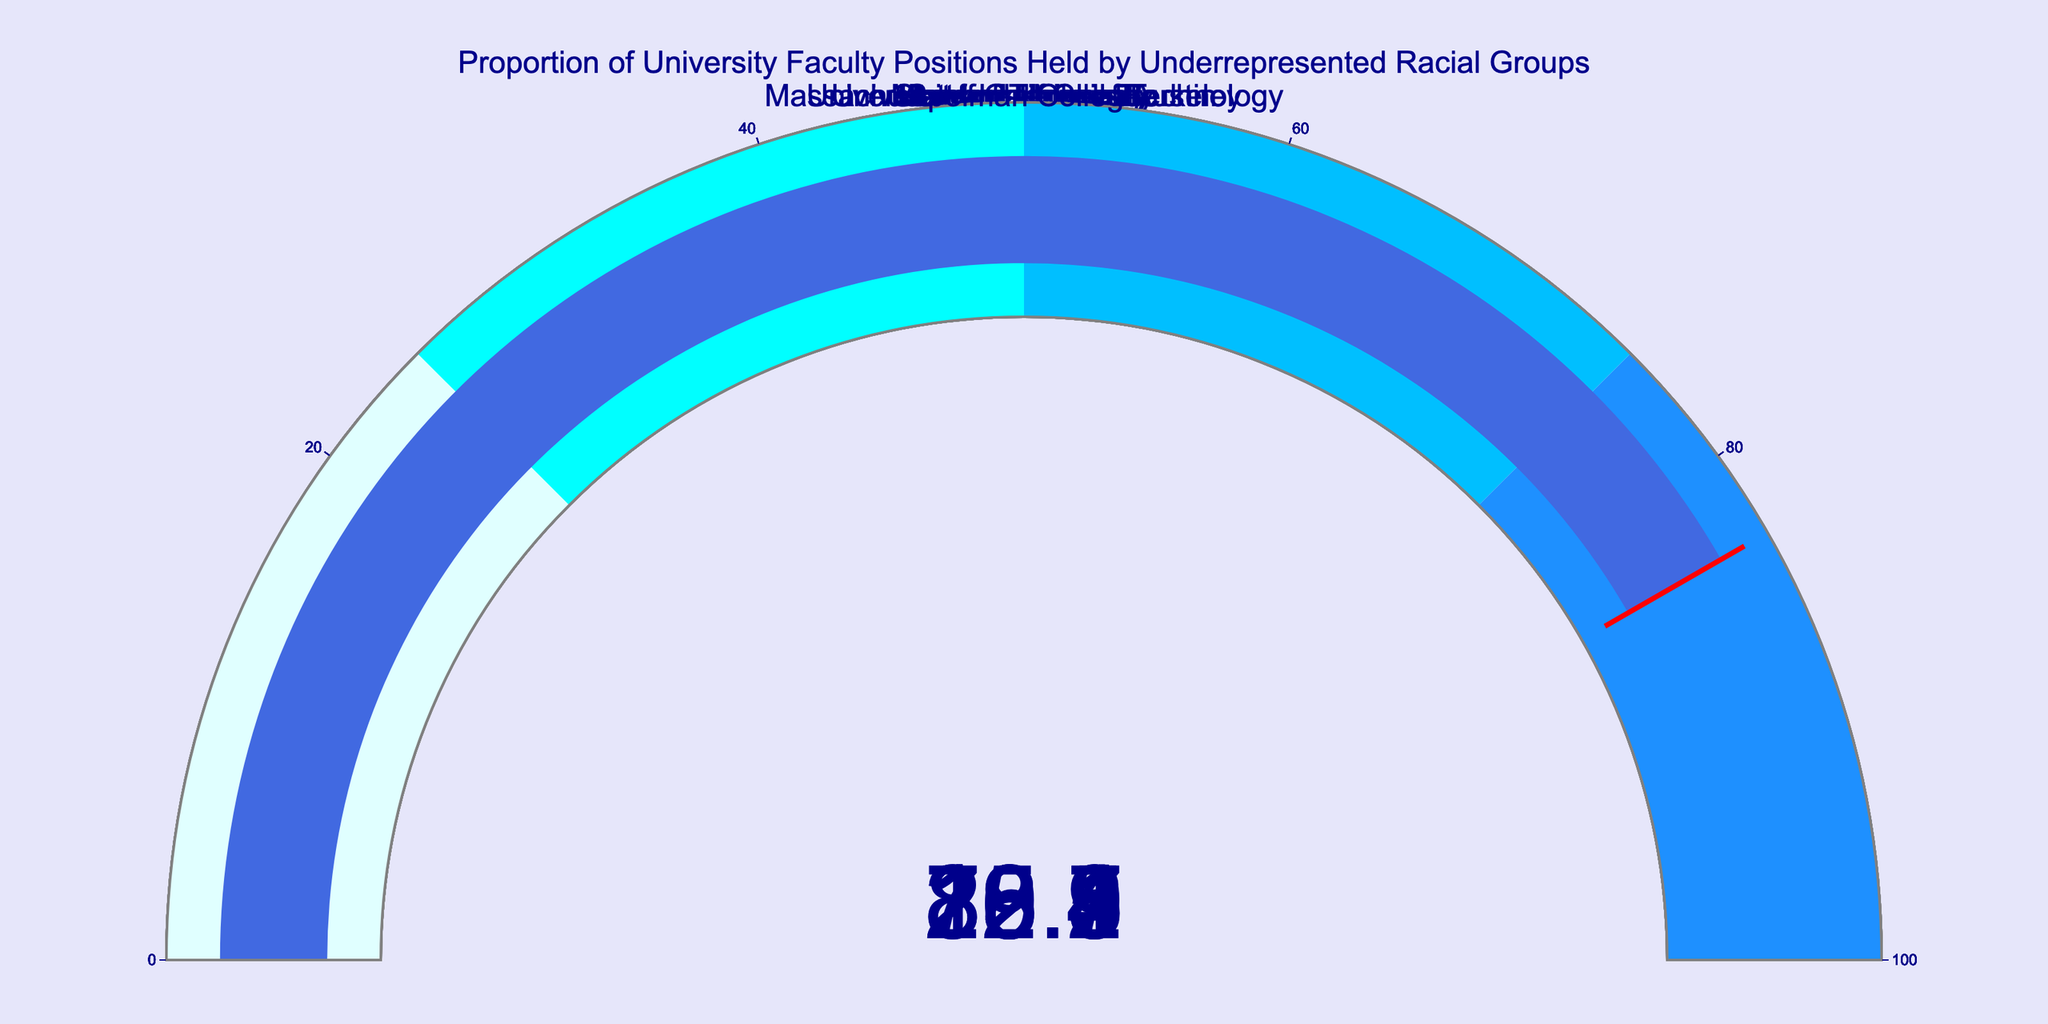What is the title of the plot? The title of the plot is usually displayed at the top. In this plot, it is clearly shown as "Proportion of University Faculty Positions Held by Underrepresented Racial Groups".
Answer: Proportion of University Faculty Positions Held by Underrepresented Racial Groups Which institution has the highest percentage of faculty positions held by underrepresented racial groups? To find the institution with the highest percentage, look at each gauge and compare the percentages displayed. Morehouse College has the highest percentage at 89.1%.
Answer: Morehouse College How many institutions are depicted in the plot? By counting the number of gauges, we identify that there are eight different institutions represented in the plot.
Answer: 8 What is the percentage of faculty positions held by underrepresented racial groups at Harvard University? The gauge for Harvard University shows a percentage of 12.5%.
Answer: 12.5% Compare the percentages of underrepresented racial groups in faculty positions between Harvard University and Howard University. Which institution has a higher percentage and by how much? Harvard University has 12.5%, while Howard University has 76.2%. Subtracting 12.5% from 76.2% gives a difference of 63.7%, indicating that Howard University has a higher percentage by 63.7%.
Answer: Howard University by 63.7% What is the average percentage of faculty positions held by underrepresented racial groups across all institutions? To compute the average, sum all the percentages (12.5 + 18.3 + 22.7 + 76.2 + 15.9 + 89.1 + 20.8 + 83.4 = 339.9) and divide by the number of institutions (8). This yields an average percentage of 339.9 / 8 = 42.49%.
Answer: 42.49% Is the percentage of faculty positions held by underrepresented racial groups at the University of California Berkeley more or less than double that of Massachusetts Institute of Technology? University of California Berkeley has 22.7%, and Massachusetts Institute of Technology has 15.9%. Doubling MIT's percentage gives 15.9 * 2 = 31.8%. Since 22.7% is less than 31.8%, Berkeley's percentage is less than double of MIT's.
Answer: Less Which institution has the lowest percentage of faculty positions held by underrepresented racial groups, and what is the percentage? By inspecting the gauges for all institutions, Harvard University has the lowest percentage at 12.5%.
Answer: Harvard University, 12.5% What is the combined percentage of faculty positions held by underrepresented racial groups at all historically black colleges and universities (HBCUs) depicted in the plot? The HBCUs in the plot are Howard University (76.2%), Morehouse College (89.1%), and Spelman College (83.4%). Summing these, we get 76.2 + 89.1 + 83.4 = 248.7%.
Answer: 248.7% Calculate the range of percentages shown in the plot. The range is calculated by subtracting the smallest percentage from the largest percentage. The largest percentage is 89.1% (Morehouse College), and the smallest is 12.5% (Harvard University). Thus, the range is 89.1 - 12.5 = 76.6%.
Answer: 76.6% 